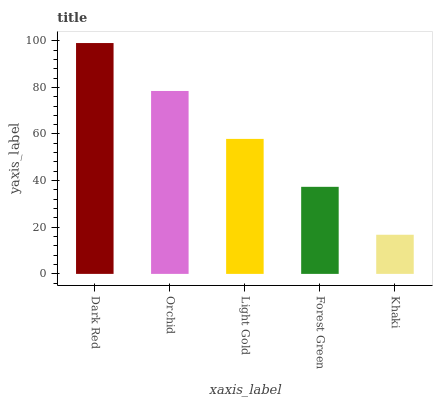Is Khaki the minimum?
Answer yes or no. Yes. Is Dark Red the maximum?
Answer yes or no. Yes. Is Orchid the minimum?
Answer yes or no. No. Is Orchid the maximum?
Answer yes or no. No. Is Dark Red greater than Orchid?
Answer yes or no. Yes. Is Orchid less than Dark Red?
Answer yes or no. Yes. Is Orchid greater than Dark Red?
Answer yes or no. No. Is Dark Red less than Orchid?
Answer yes or no. No. Is Light Gold the high median?
Answer yes or no. Yes. Is Light Gold the low median?
Answer yes or no. Yes. Is Forest Green the high median?
Answer yes or no. No. Is Orchid the low median?
Answer yes or no. No. 